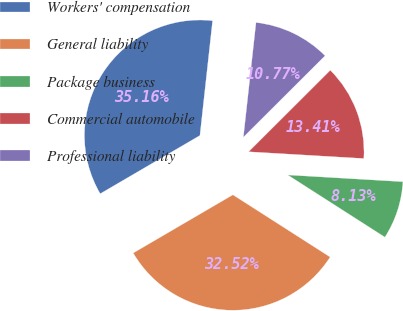Convert chart to OTSL. <chart><loc_0><loc_0><loc_500><loc_500><pie_chart><fcel>Workers' compensation<fcel>General liability<fcel>Package business<fcel>Commercial automobile<fcel>Professional liability<nl><fcel>35.16%<fcel>32.52%<fcel>8.13%<fcel>13.41%<fcel>10.77%<nl></chart> 